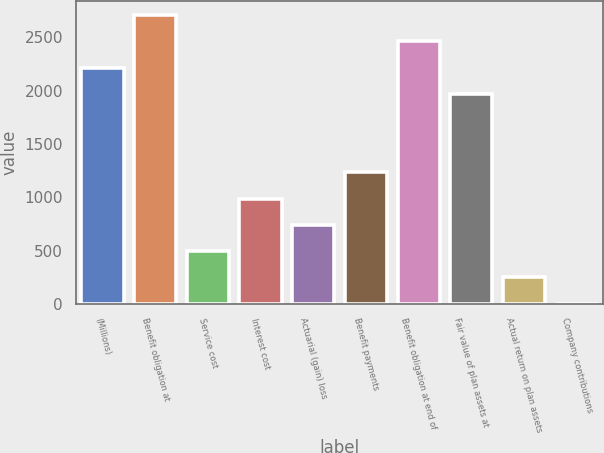Convert chart to OTSL. <chart><loc_0><loc_0><loc_500><loc_500><bar_chart><fcel>(Millions)<fcel>Benefit obligation at<fcel>Service cost<fcel>Interest cost<fcel>Actuarial (gain) loss<fcel>Benefit payments<fcel>Benefit obligation at end of<fcel>Fair value of plan assets at<fcel>Actual return on plan assets<fcel>Company contributions<nl><fcel>2216.1<fcel>2707.9<fcel>494.8<fcel>986.6<fcel>740.7<fcel>1232.5<fcel>2462<fcel>1970.2<fcel>248.9<fcel>3<nl></chart> 